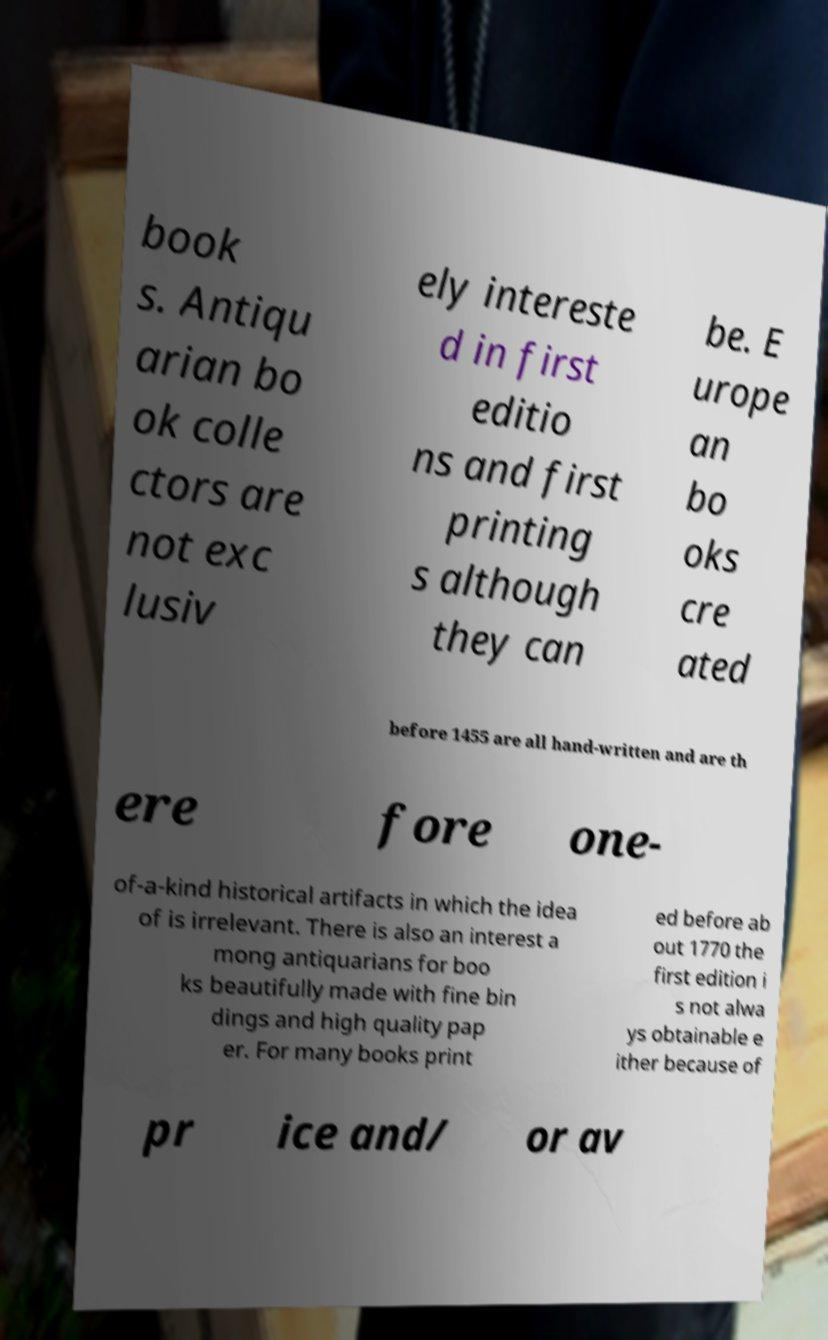For documentation purposes, I need the text within this image transcribed. Could you provide that? book s. Antiqu arian bo ok colle ctors are not exc lusiv ely intereste d in first editio ns and first printing s although they can be. E urope an bo oks cre ated before 1455 are all hand-written and are th ere fore one- of-a-kind historical artifacts in which the idea of is irrelevant. There is also an interest a mong antiquarians for boo ks beautifully made with fine bin dings and high quality pap er. For many books print ed before ab out 1770 the first edition i s not alwa ys obtainable e ither because of pr ice and/ or av 